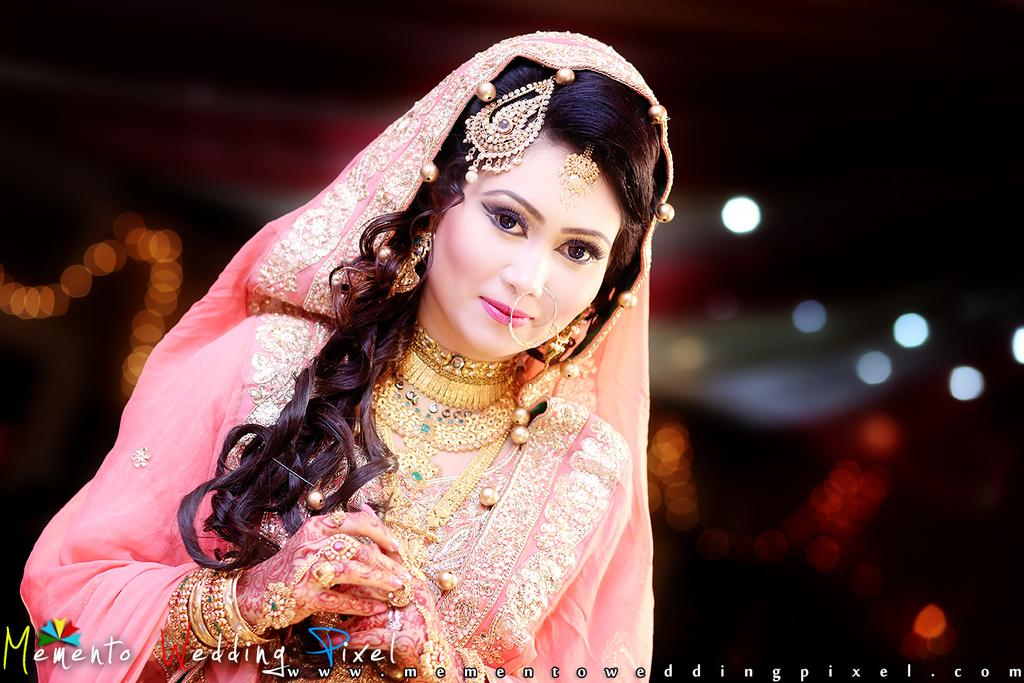Who is the main subject in the image? There is a girl in the image. What is the girl wearing in the image? The girl is wearing a pink color dress and gold jewelry on her neck, hand, and head. What type of flowers can be seen in the girl's hair in the image? There are no flowers visible in the girl's hair in the image. 